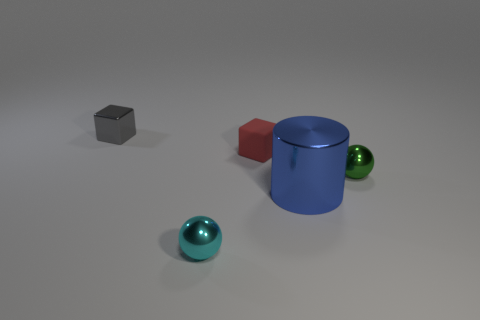Add 3 red rubber blocks. How many objects exist? 8 Subtract all cylinders. How many objects are left? 4 Subtract 0 green cubes. How many objects are left? 5 Subtract all blue objects. Subtract all big blue metal objects. How many objects are left? 3 Add 5 small red matte objects. How many small red matte objects are left? 6 Add 3 small cyan objects. How many small cyan objects exist? 4 